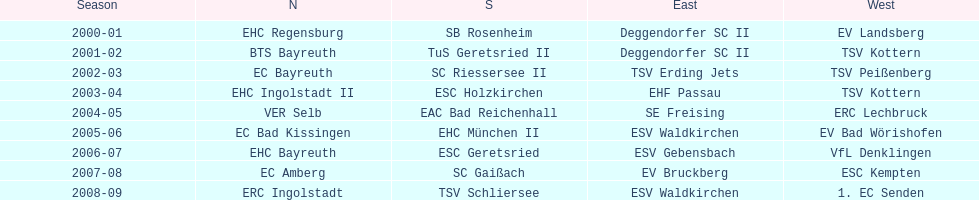Could you parse the entire table? {'header': ['Season', 'N', 'S', 'East', 'West'], 'rows': [['2000-01', 'EHC Regensburg', 'SB Rosenheim', 'Deggendorfer SC II', 'EV Landsberg'], ['2001-02', 'BTS Bayreuth', 'TuS Geretsried II', 'Deggendorfer SC II', 'TSV Kottern'], ['2002-03', 'EC Bayreuth', 'SC Riessersee II', 'TSV Erding Jets', 'TSV Peißenberg'], ['2003-04', 'EHC Ingolstadt II', 'ESC Holzkirchen', 'EHF Passau', 'TSV Kottern'], ['2004-05', 'VER Selb', 'EAC Bad Reichenhall', 'SE Freising', 'ERC Lechbruck'], ['2005-06', 'EC Bad Kissingen', 'EHC München II', 'ESV Waldkirchen', 'EV Bad Wörishofen'], ['2006-07', 'EHC Bayreuth', 'ESC Geretsried', 'ESV Gebensbach', 'VfL Denklingen'], ['2007-08', 'EC Amberg', 'SC Gaißach', 'EV Bruckberg', 'ESC Kempten'], ['2008-09', 'ERC Ingolstadt', 'TSV Schliersee', 'ESV Waldkirchen', '1. EC Senden']]} Which name appears more often, kottern or bayreuth? Bayreuth. 